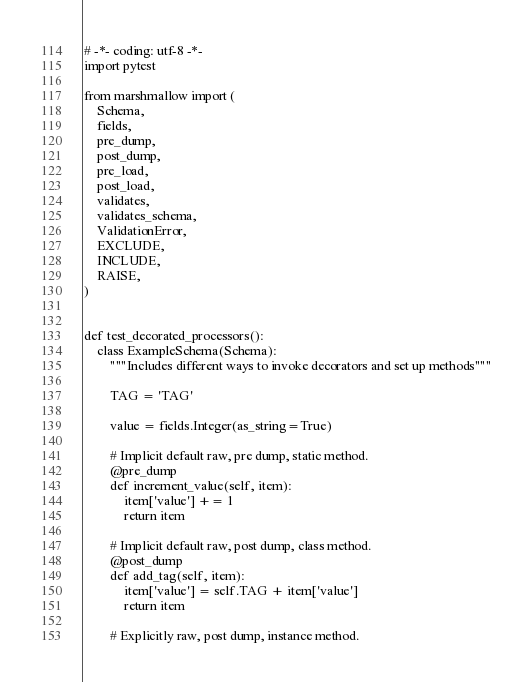<code> <loc_0><loc_0><loc_500><loc_500><_Python_># -*- coding: utf-8 -*-
import pytest

from marshmallow import (
    Schema,
    fields,
    pre_dump,
    post_dump,
    pre_load,
    post_load,
    validates,
    validates_schema,
    ValidationError,
    EXCLUDE,
    INCLUDE,
    RAISE,
)


def test_decorated_processors():
    class ExampleSchema(Schema):
        """Includes different ways to invoke decorators and set up methods"""

        TAG = 'TAG'

        value = fields.Integer(as_string=True)

        # Implicit default raw, pre dump, static method.
        @pre_dump
        def increment_value(self, item):
            item['value'] += 1
            return item

        # Implicit default raw, post dump, class method.
        @post_dump
        def add_tag(self, item):
            item['value'] = self.TAG + item['value']
            return item

        # Explicitly raw, post dump, instance method.</code> 